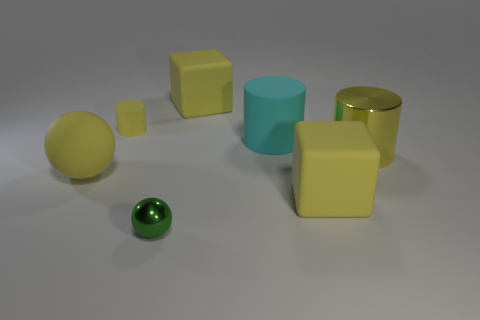Subtract all blue blocks. How many yellow cylinders are left? 2 Subtract all yellow cylinders. How many cylinders are left? 1 Add 1 yellow matte cylinders. How many objects exist? 8 Subtract all cylinders. How many objects are left? 4 Subtract all large gray metal blocks. Subtract all cyan rubber things. How many objects are left? 6 Add 1 yellow rubber cylinders. How many yellow rubber cylinders are left? 2 Add 3 gray cylinders. How many gray cylinders exist? 3 Subtract 0 red cylinders. How many objects are left? 7 Subtract all green cylinders. Subtract all brown spheres. How many cylinders are left? 3 